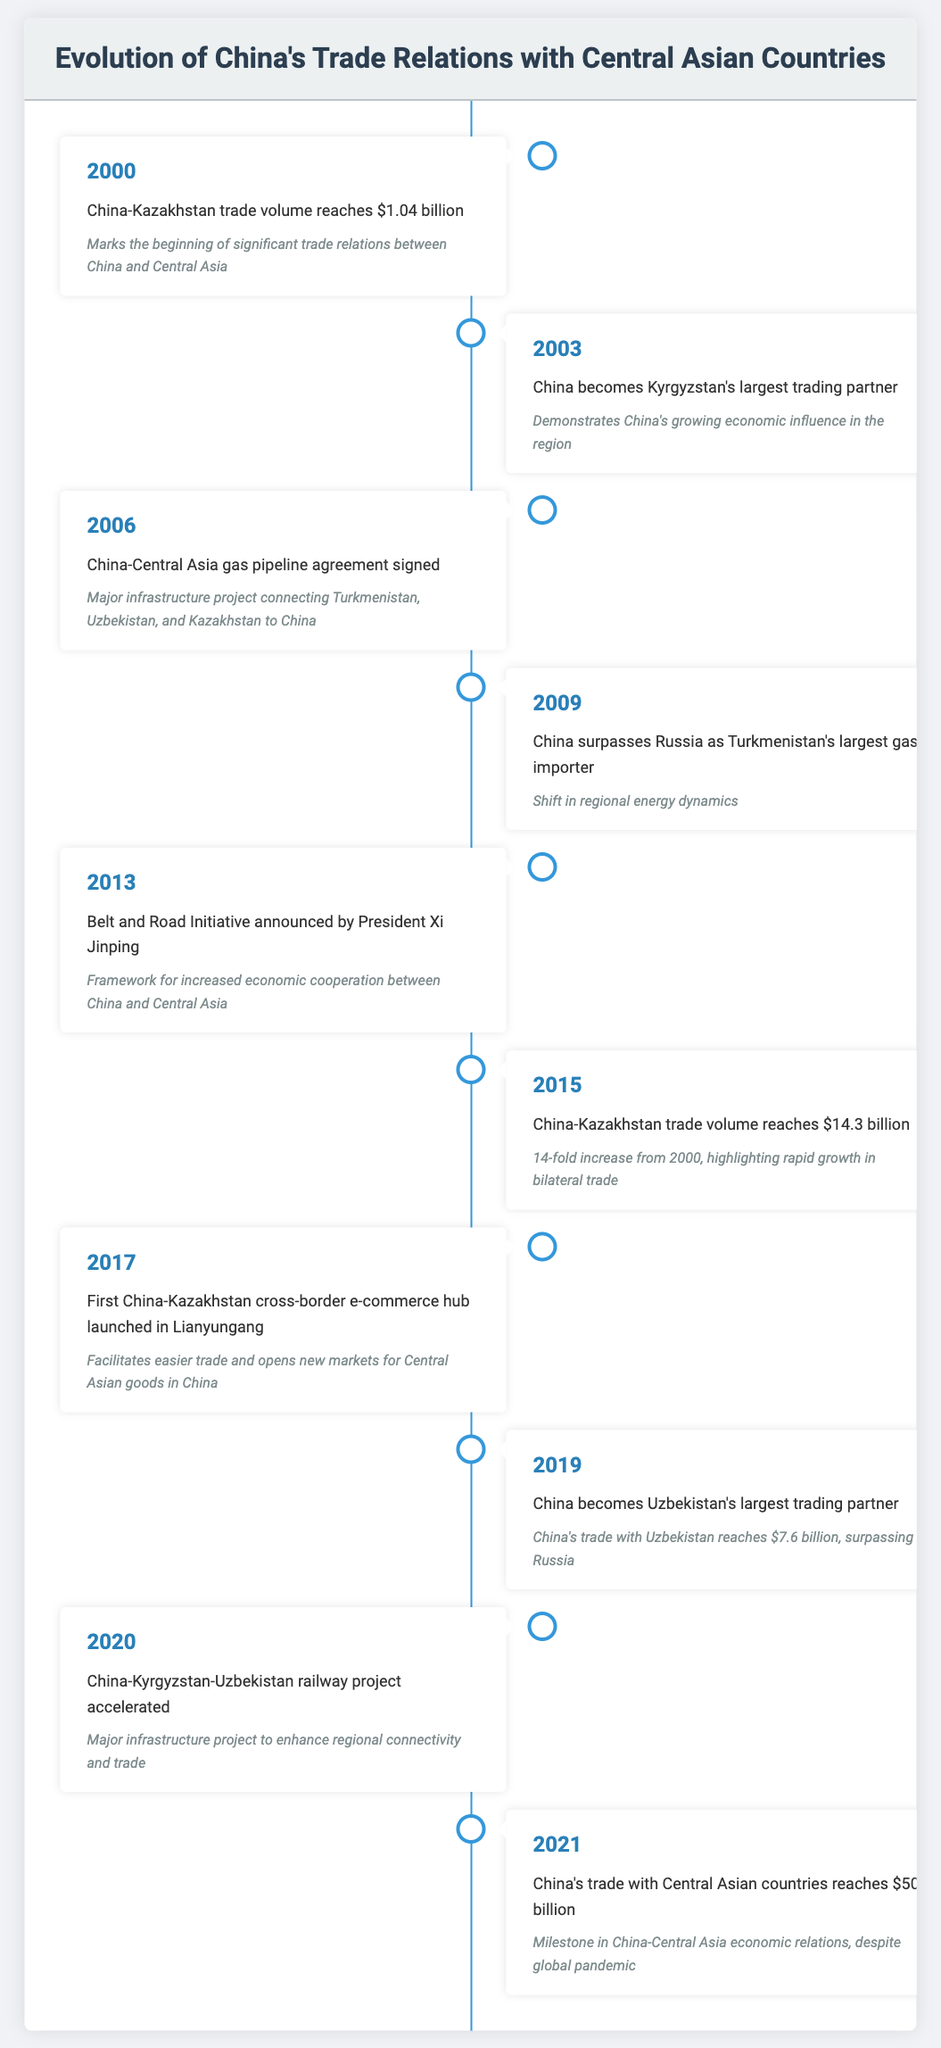What year did China-Kazakhstan trade volume first exceed $1 billion? According to the table, the trade volume between China and Kazakhstan reached $1.04 billion in the year 2000, which marks the first instance exceeding $1 billion.
Answer: 2000 In what year did China become Kyrgyzstan's largest trading partner? The table lists the year 2003 as the time when China became Kyrgyzstan's largest trading partner.
Answer: 2003 What is the increase in trade volume between China and Kazakhstan from 2000 to 2015? The trade volume in 2000 was $1.04 billion and in 2015, it reached $14.3 billion. The increase is calculated as $14.3 billion minus $1.04 billion, which equals $13.26 billion.
Answer: 13.26 billion Did China surpass Russia as Turkmenistan's largest gas importer? Yes, the table indicates that in 2009, China did indeed surpass Russia to become Turkmenistan's largest gas importer.
Answer: Yes What was the trade volume between China and Uzbekistan in 2019? The table specifies that in 2019, China's trade with Uzbekistan reached $7.6 billion.
Answer: 7.6 billion How many years after the announcement of the Belt and Road Initiative did China's trade with Central Asian countries reach $50 billion? The Belt and Road Initiative was announced in 2013 and China's trade with Central Asian countries reached $50 billion in 2021. The number of years between these two events is calculated as 2021 minus 2013, which equals 8 years.
Answer: 8 years Which event signifies a major shift in regional energy dynamics? The table highlights that in 2009, China surpassed Russia as Turkmenistan's largest gas importer, signifying a major shift in regional energy dynamics.
Answer: China surpasses Russia as Turkmenistan's largest gas importer What were the significant years for infrastructure developments related to trade in Central Asia? The table notes two significant years: 2006 when the China-Central Asia gas pipeline agreement was signed, and 2020 when the China-Kyrgyzstan-Uzbekistan railway project was accelerated. This indicates ongoing infrastructure development during these years.
Answer: 2006 and 2020 